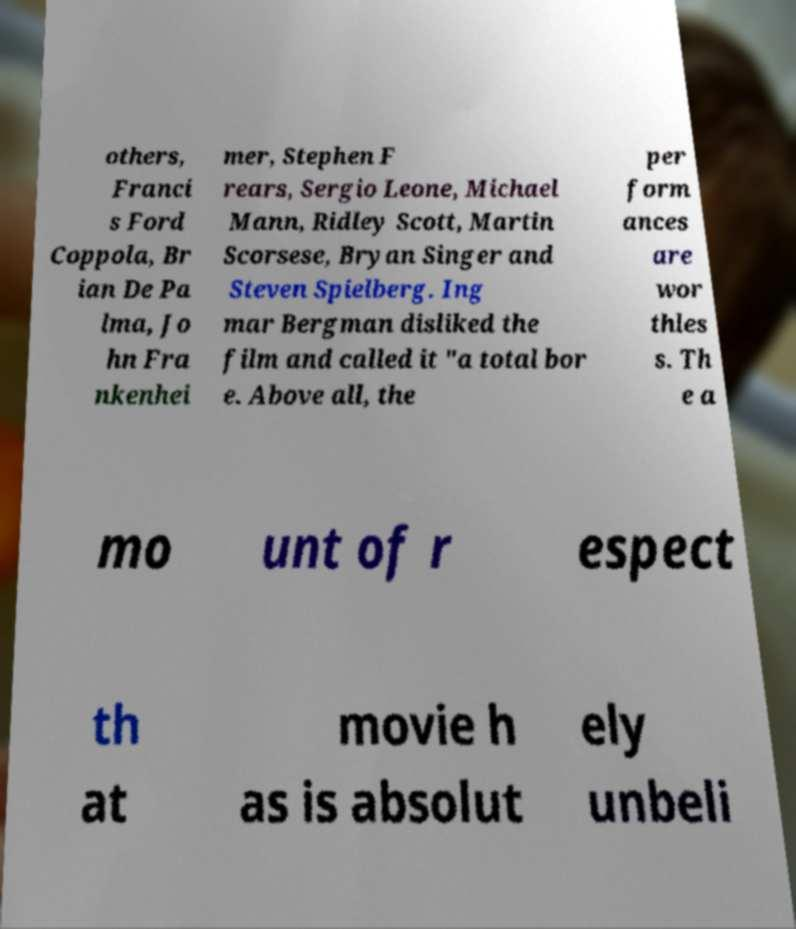Please identify and transcribe the text found in this image. others, Franci s Ford Coppola, Br ian De Pa lma, Jo hn Fra nkenhei mer, Stephen F rears, Sergio Leone, Michael Mann, Ridley Scott, Martin Scorsese, Bryan Singer and Steven Spielberg. Ing mar Bergman disliked the film and called it "a total bor e. Above all, the per form ances are wor thles s. Th e a mo unt of r espect th at movie h as is absolut ely unbeli 